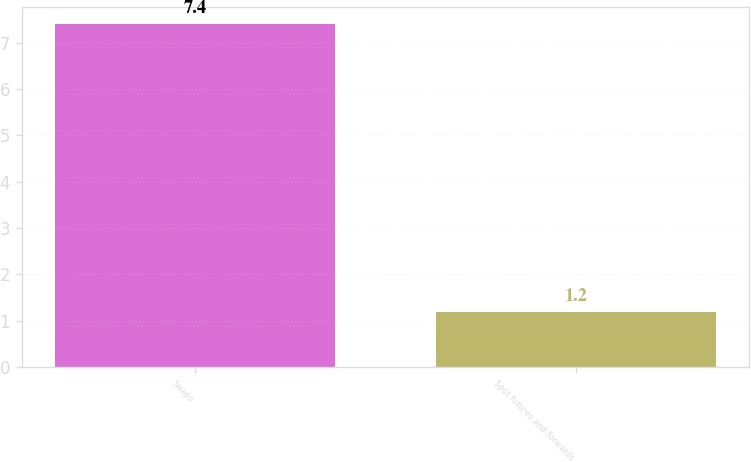<chart> <loc_0><loc_0><loc_500><loc_500><bar_chart><fcel>Swaps<fcel>Spot futures and forwards<nl><fcel>7.4<fcel>1.2<nl></chart> 